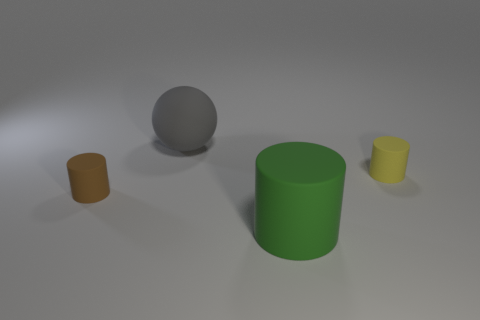Is there anything else that has the same material as the brown thing?
Keep it short and to the point. Yes. What is the large sphere made of?
Offer a terse response. Rubber. Is there any other thing that has the same color as the large cylinder?
Your answer should be very brief. No. Is the gray rubber object the same shape as the brown rubber thing?
Your answer should be compact. No. There is a matte cylinder on the left side of the big gray matte object on the left side of the small thing to the right of the green matte cylinder; what size is it?
Offer a very short reply. Small. How many other objects are there of the same material as the brown object?
Offer a very short reply. 3. There is a object to the left of the big gray matte thing; what color is it?
Make the answer very short. Brown. The small cylinder that is to the left of the small matte object on the right side of the small matte thing that is to the left of the green thing is made of what material?
Offer a terse response. Rubber. Are there any tiny yellow rubber things that have the same shape as the big gray thing?
Make the answer very short. No. There is a matte thing that is the same size as the brown cylinder; what is its shape?
Make the answer very short. Cylinder. 